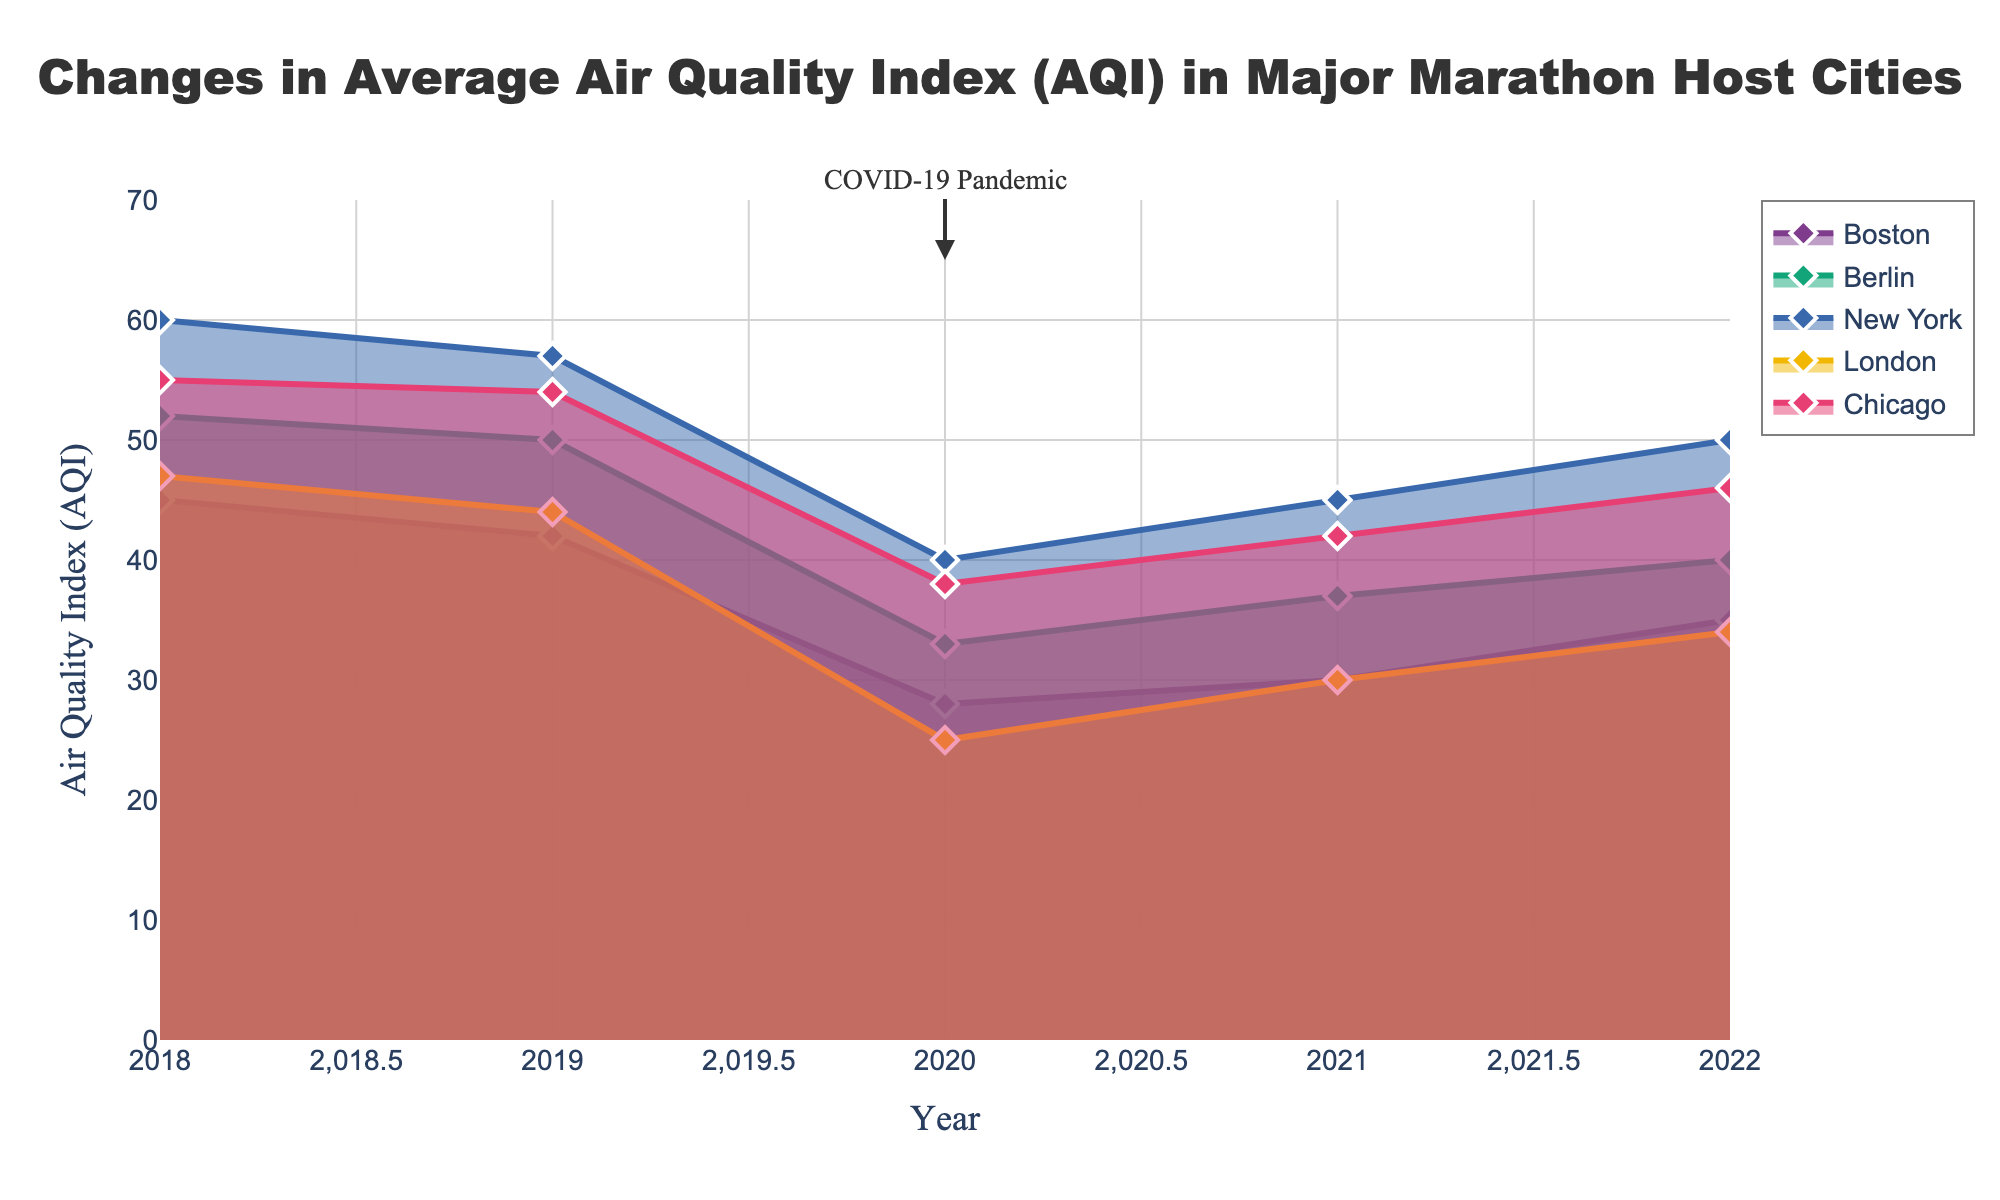What's the title of the figure? The title of the figure is stated in the top center of the plot.
Answer: Changes in Average Air Quality Index (AQI) in Major Marathon Host Cities Which city had the lowest AQI in 2020? By examining the labels on the x-axis and the corresponding data points for 2020, you can see that London had the lowest AQI around 25 in 2020.
Answer: London What was the AQI in Boston in 2021? Locate the data points for Boston and find the one marked for 2021 to see the AQI value. The data point for 2021 shows an AQI of 30 for Boston.
Answer: 30 Which city showed the largest decrease in AQI from 2019 to 2020? Compare the AQI values for 2019 and 2020 for each city and find the one with the largest difference. For Berlin, the AQI dropped from 50 (2019) to 33 (2020), a decrease of 17 units, which is the highest.
Answer: Berlin List all cities that experienced a decrease in AQI between 2019 and 2020. Look at the AQI values for each city in 2019 and 2020. Boston (42 to 28), Berlin (50 to 33), New York (57 to 40), London (44 to 25), and Chicago (54 to 38) all saw a decrease in AQI.
Answer: Boston, Berlin, New York, London, Chicago How did New York's AQI change from 2020 to 2022? Identify the AQI values for New York in 2020, 2021, and 2022. The AQI was 40 in 2020, then increased to 45 in 2021, and increased again to 50 in 2022. Therefore, it increased by 10 units over this period.
Answer: Increased by 10 Which year marked an annotation noting the "COVID-19 Pandemic"? Look for any annotations on the plot and note the year mentioned. The annotation "COVID-19 Pandemic" is directly on the year 2020.
Answer: 2020 In 2022, which city's AQI was closest to 35? Compare the AQI values of all cities in 2022 to see which one is nearest to 35. Both Boston and London have AQI values close to 35 in 2022, with Boston at 35 and London at 34.
Answer: Boston and London What general trend can be observed in AQI levels during the pandemic year of 2020 across the cities? Look at the AQI values for 2020 across all cities to identify a common pattern. All cities showed a substantial decrease in AQI during the pandemic year 2020.
Answer: Decrease in AQI Between 2018 and 2022, which city experienced the highest AQI in any year, and what was the value? Identify the maximum AQI value on the y-axis and find the corresponding city and year. New York had the highest AQI value of 60 in 2018.
Answer: New York, 60 